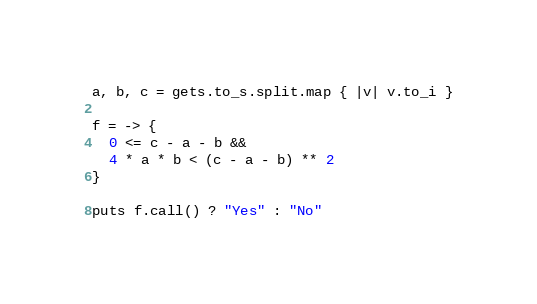<code> <loc_0><loc_0><loc_500><loc_500><_Crystal_>a, b, c = gets.to_s.split.map { |v| v.to_i }

f = -> {
  0 <= c - a - b &&
  4 * a * b < (c - a - b) ** 2
}

puts f.call() ? "Yes" : "No"
</code> 